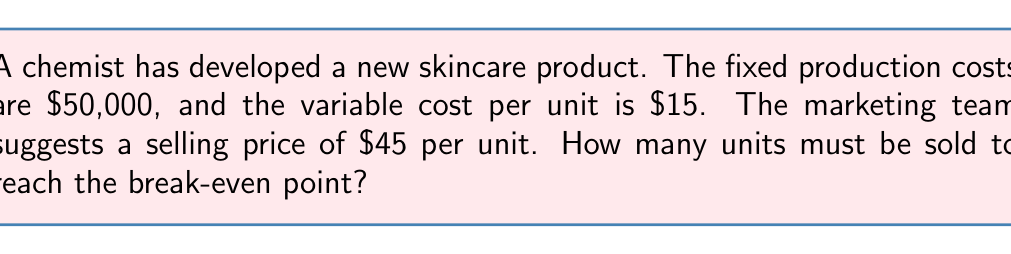Solve this math problem. To solve this problem, we need to use the break-even formula:

Break-even point = Fixed Costs / (Price per unit - Variable Cost per unit)

Let's break it down step-by-step:

1. Identify the given values:
   Fixed Costs (FC) = $50,000
   Variable Cost per unit (VC) = $15
   Selling Price per unit (P) = $45

2. Calculate the contribution margin per unit:
   Contribution Margin = P - VC
   $$ CM = 45 - 15 = 30 $$

3. Apply the break-even formula:
   $$ BE = \frac{FC}{CM} $$
   $$ BE = \frac{50,000}{30} $$

4. Solve the equation:
   $$ BE = 1,666.67 $$

5. Since we can't sell a fraction of a unit, we round up to the nearest whole number:
   Break-even point = 1,667 units

Therefore, the company needs to sell 1,667 units of the new skincare product to reach the break-even point.
Answer: 1,667 units 